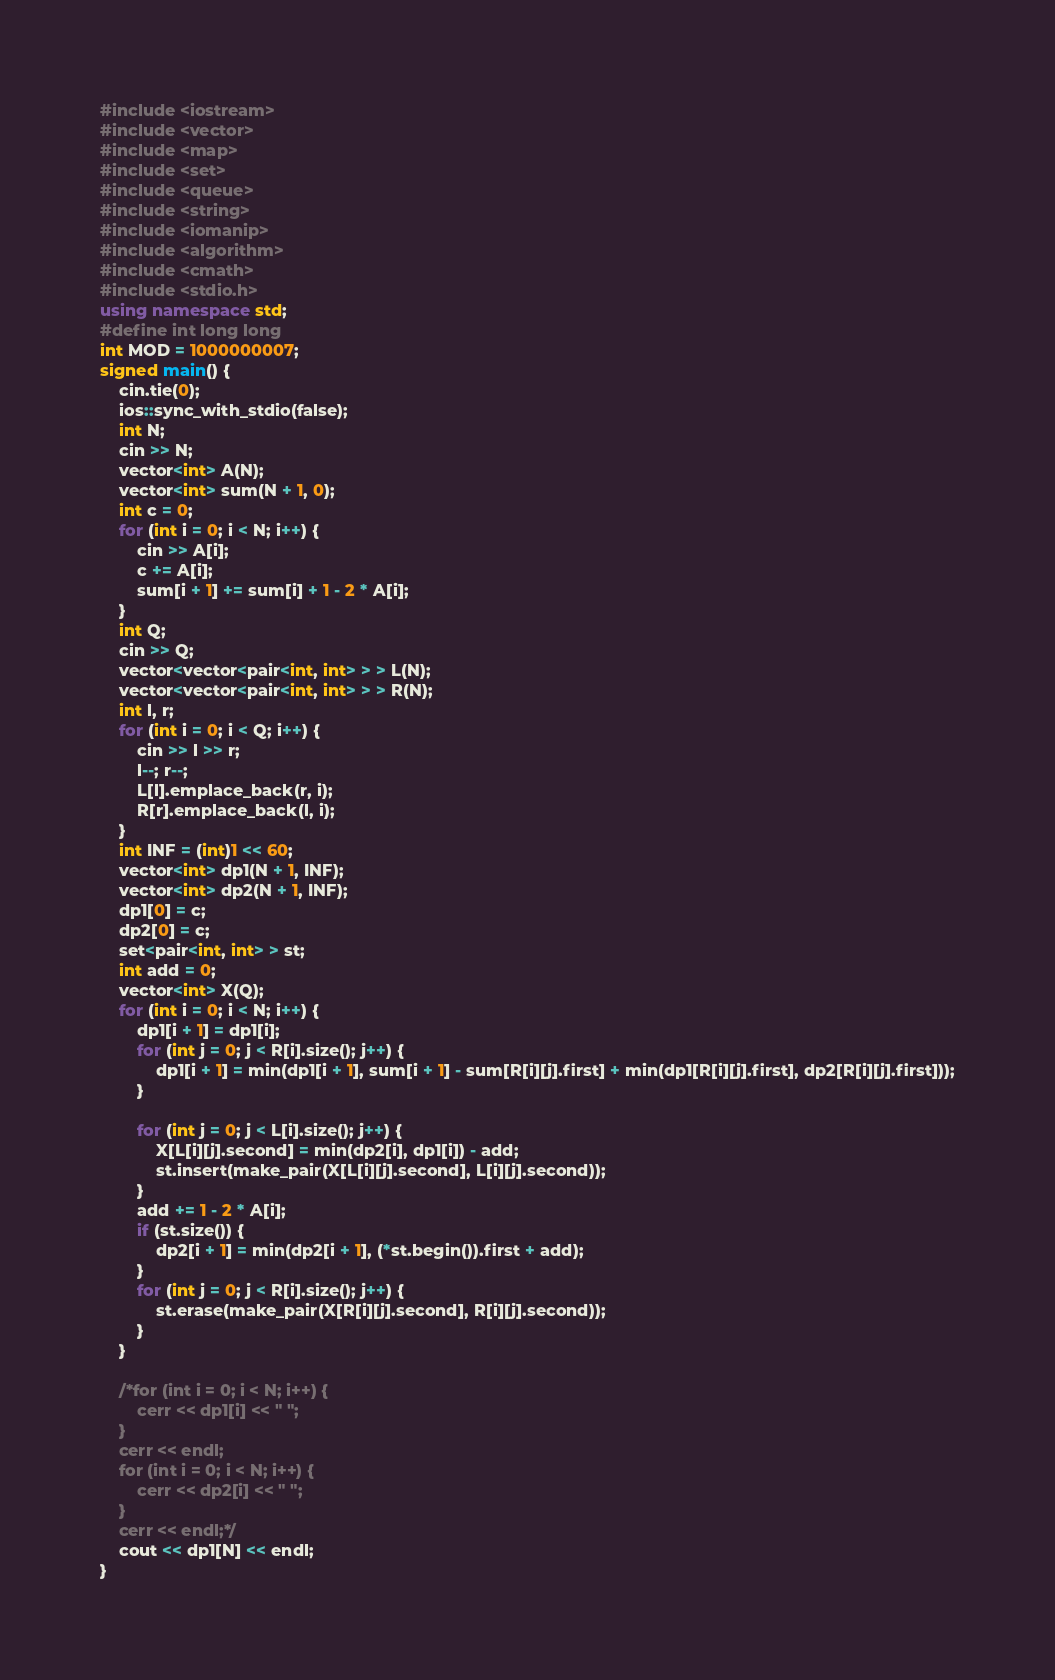Convert code to text. <code><loc_0><loc_0><loc_500><loc_500><_C++_>#include <iostream>
#include <vector>
#include <map>
#include <set>
#include <queue>
#include <string>
#include <iomanip>
#include <algorithm>
#include <cmath>
#include <stdio.h>
using namespace std;
#define int long long
int MOD = 1000000007;
signed main() {
	cin.tie(0);
	ios::sync_with_stdio(false);
	int N;
	cin >> N;
	vector<int> A(N);
	vector<int> sum(N + 1, 0);
	int c = 0;
	for (int i = 0; i < N; i++) {
		cin >> A[i];
		c += A[i];
		sum[i + 1] += sum[i] + 1 - 2 * A[i];
	}
	int Q;
	cin >> Q;
	vector<vector<pair<int, int> > > L(N);
	vector<vector<pair<int, int> > > R(N);
	int l, r;
	for (int i = 0; i < Q; i++) {
		cin >> l >> r;
		l--; r--;
		L[l].emplace_back(r, i);
		R[r].emplace_back(l, i);
	}
	int INF = (int)1 << 60;
	vector<int> dp1(N + 1, INF);
	vector<int> dp2(N + 1, INF);
	dp1[0] = c;
	dp2[0] = c;
	set<pair<int, int> > st;
	int add = 0;
	vector<int> X(Q);
	for (int i = 0; i < N; i++) {
		dp1[i + 1] = dp1[i];
		for (int j = 0; j < R[i].size(); j++) {
			dp1[i + 1] = min(dp1[i + 1], sum[i + 1] - sum[R[i][j].first] + min(dp1[R[i][j].first], dp2[R[i][j].first]));
		}
		
		for (int j = 0; j < L[i].size(); j++) {
			X[L[i][j].second] = min(dp2[i], dp1[i]) - add;
			st.insert(make_pair(X[L[i][j].second], L[i][j].second));
		}
		add += 1 - 2 * A[i];
		if (st.size()) {
			dp2[i + 1] = min(dp2[i + 1], (*st.begin()).first + add);
		}
		for (int j = 0; j < R[i].size(); j++) {
			st.erase(make_pair(X[R[i][j].second], R[i][j].second));
		}
	}

	/*for (int i = 0; i < N; i++) {
		cerr << dp1[i] << " ";
	}
	cerr << endl;
	for (int i = 0; i < N; i++) {
		cerr << dp2[i] << " ";
	}
	cerr << endl;*/
	cout << dp1[N] << endl;
}</code> 